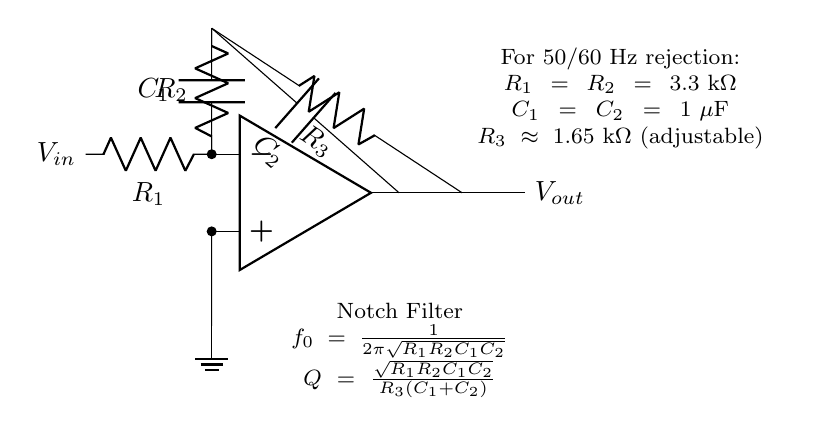What type of filter is represented in the circuit? The circuit is labeled as a Notch Filter, which is specifically designed to reject a narrow band of frequencies, such as power line interference.
Answer: Notch Filter What are the capacitance values used in this circuit? The circuit indicates that both capacitors, C1 and C2, have a value of one microfarad each, as stated in the section about components.
Answer: One microfarad What is the purpose of R3 in this circuit? R3 is an adjustable resistor that helps to set the quality factor (Q) of the notch filter, which affects the selectivity of the filter around the notch frequency.
Answer: Adjustable resistor What is the notch frequency formula provided in the circuit? The notch frequency is calculated using the formula \( f_0 = \frac{1}{2\pi\sqrt{R_1R_2C_1C_2}} \), which combines the resistances and capacitances in the circuit to determine the frequency at which interference is reduced.
Answer: Frequency formula What values of resistors R1 and R2 are used in the circuit? According to the component specifications in the circuit, both resistors R1 and R2 are set to three point three kilo-ohms each.
Answer: Three point three kilo-ohms 